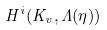<formula> <loc_0><loc_0><loc_500><loc_500>H ^ { i } ( K _ { v } , \Lambda ( \eta ) )</formula> 